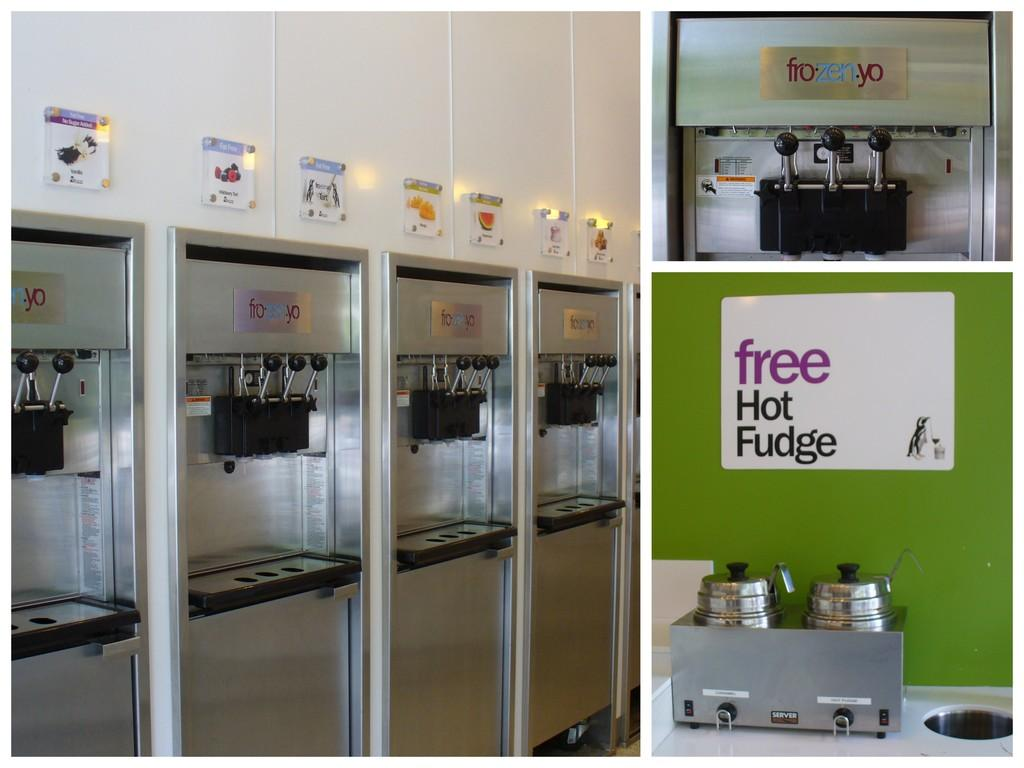<image>
Summarize the visual content of the image. A frozen yogurt shop with a sign reading "free Hot Fudge". 